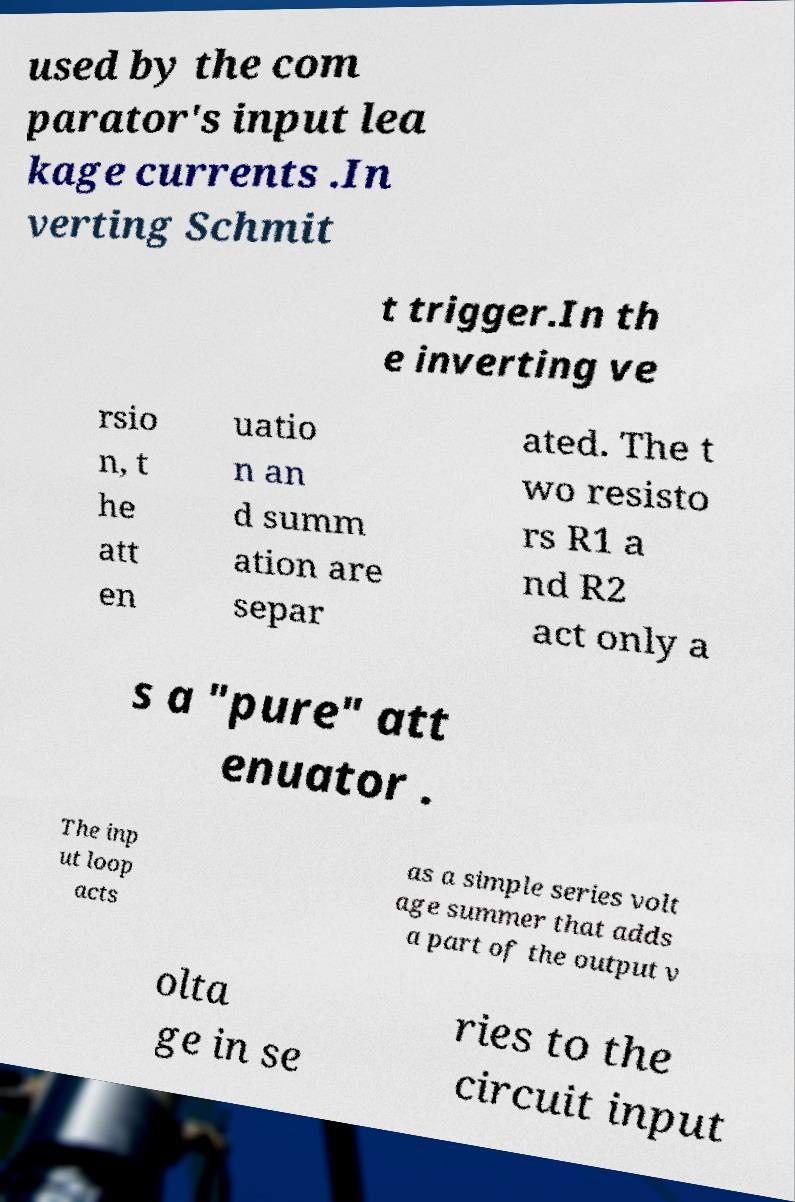Can you read and provide the text displayed in the image?This photo seems to have some interesting text. Can you extract and type it out for me? used by the com parator's input lea kage currents .In verting Schmit t trigger.In th e inverting ve rsio n, t he att en uatio n an d summ ation are separ ated. The t wo resisto rs R1 a nd R2 act only a s a "pure" att enuator . The inp ut loop acts as a simple series volt age summer that adds a part of the output v olta ge in se ries to the circuit input 